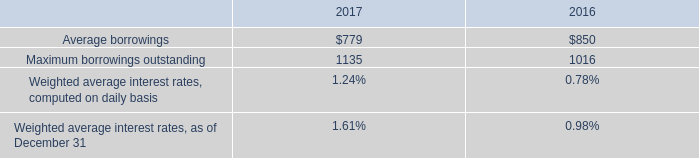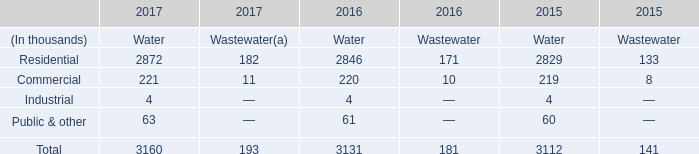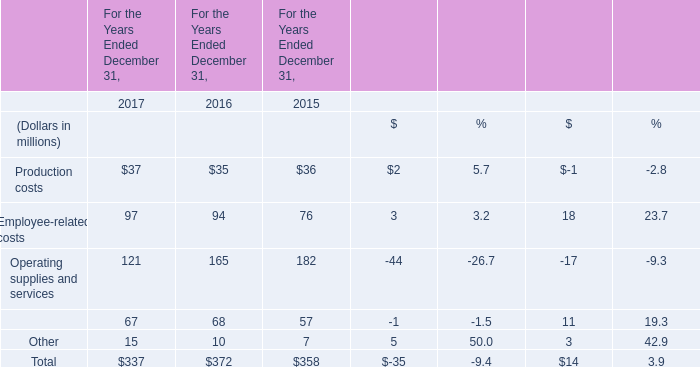what was the percentage change in the weighted average interest rates computed on daily basis from 2016 to 2017 
Computations: ((1.24 - 0.78) / 0.78)
Answer: 0.58974. 